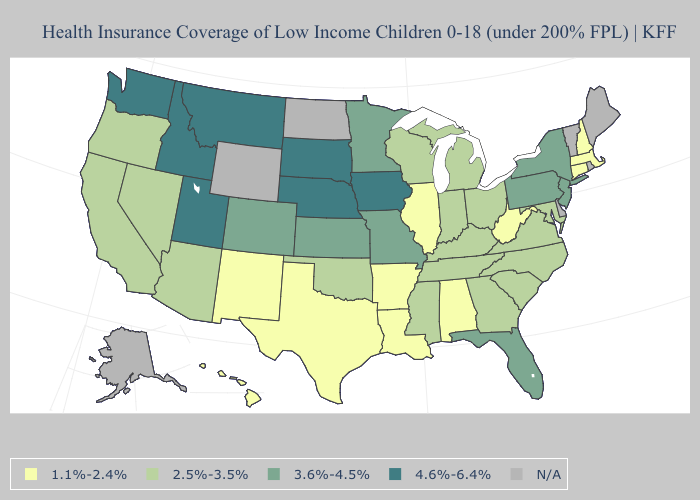What is the value of West Virginia?
Give a very brief answer. 1.1%-2.4%. What is the value of Maryland?
Concise answer only. 2.5%-3.5%. Name the states that have a value in the range 4.6%-6.4%?
Short answer required. Idaho, Iowa, Montana, Nebraska, South Dakota, Utah, Washington. How many symbols are there in the legend?
Quick response, please. 5. What is the lowest value in the MidWest?
Answer briefly. 1.1%-2.4%. Which states have the highest value in the USA?
Concise answer only. Idaho, Iowa, Montana, Nebraska, South Dakota, Utah, Washington. Does Utah have the highest value in the West?
Write a very short answer. Yes. Name the states that have a value in the range 4.6%-6.4%?
Give a very brief answer. Idaho, Iowa, Montana, Nebraska, South Dakota, Utah, Washington. What is the lowest value in the West?
Answer briefly. 1.1%-2.4%. What is the highest value in the West ?
Keep it brief. 4.6%-6.4%. Does the first symbol in the legend represent the smallest category?
Be succinct. Yes. What is the value of Texas?
Short answer required. 1.1%-2.4%. Which states hav the highest value in the West?
Short answer required. Idaho, Montana, Utah, Washington. Which states have the lowest value in the USA?
Write a very short answer. Alabama, Arkansas, Connecticut, Hawaii, Illinois, Louisiana, Massachusetts, New Hampshire, New Mexico, Texas, West Virginia. 